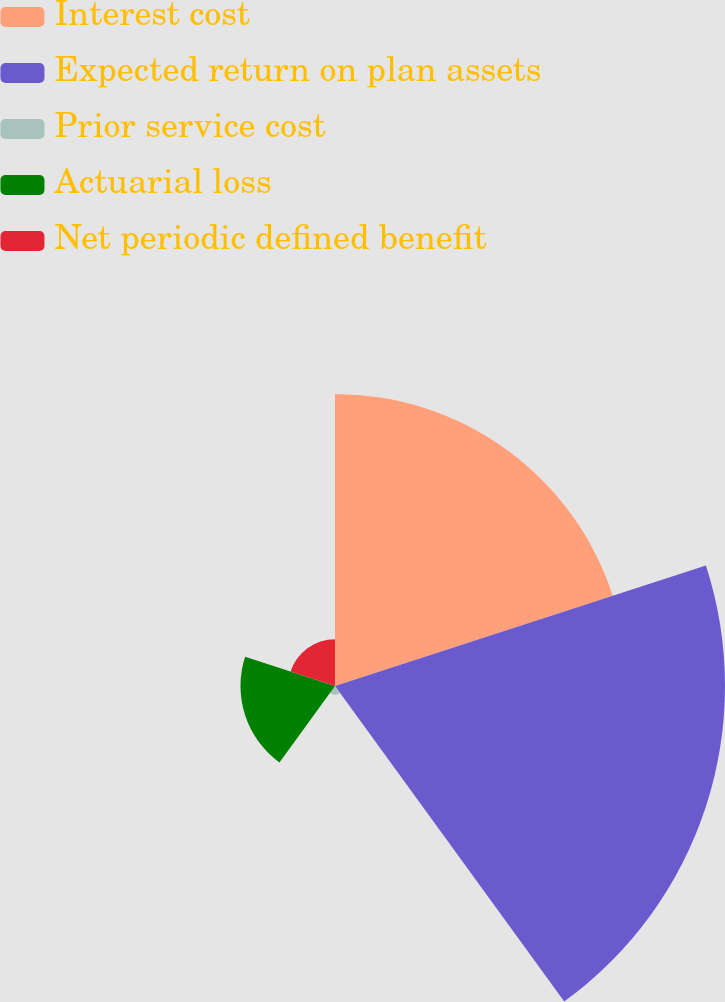Convert chart to OTSL. <chart><loc_0><loc_0><loc_500><loc_500><pie_chart><fcel>Interest cost<fcel>Expected return on plan assets<fcel>Prior service cost<fcel>Actuarial loss<fcel>Net periodic defined benefit<nl><fcel>35.11%<fcel>46.88%<fcel>1.03%<fcel>11.36%<fcel>5.62%<nl></chart> 